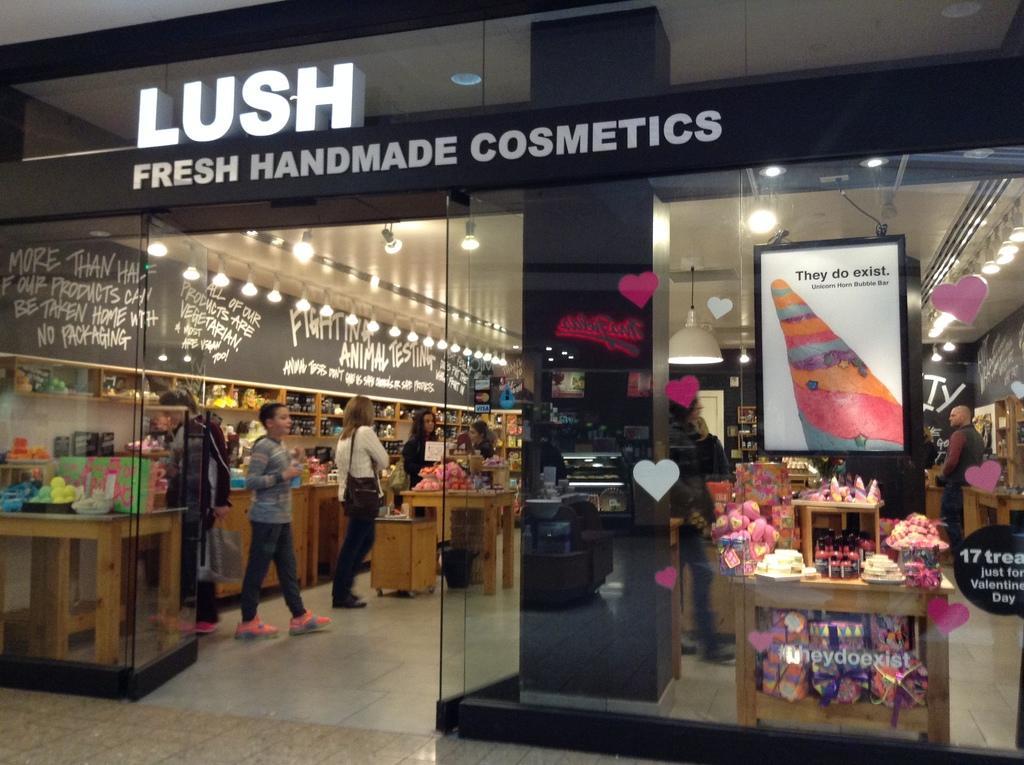Please provide a concise description of this image. In this picture there is a cosmetic store. In the store there are people, lights, text, boats and other objects. 